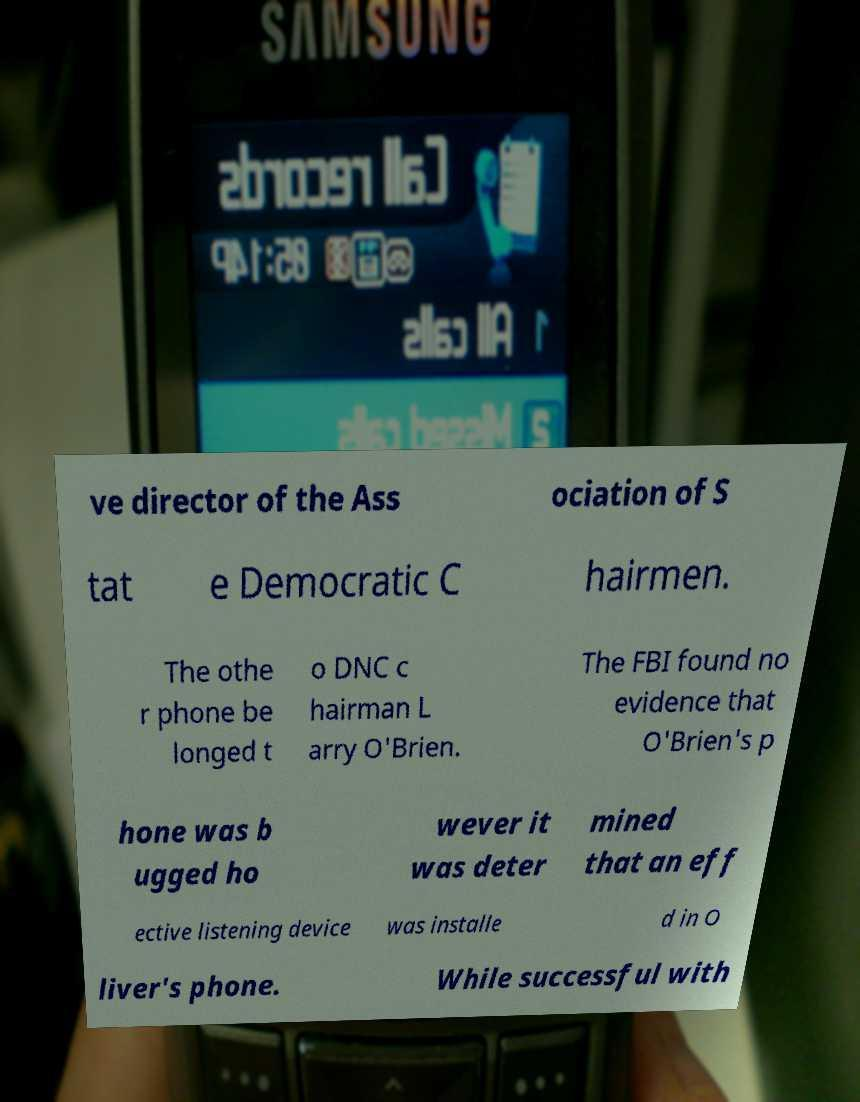What messages or text are displayed in this image? I need them in a readable, typed format. ve director of the Ass ociation of S tat e Democratic C hairmen. The othe r phone be longed t o DNC c hairman L arry O'Brien. The FBI found no evidence that O'Brien's p hone was b ugged ho wever it was deter mined that an eff ective listening device was installe d in O liver's phone. While successful with 